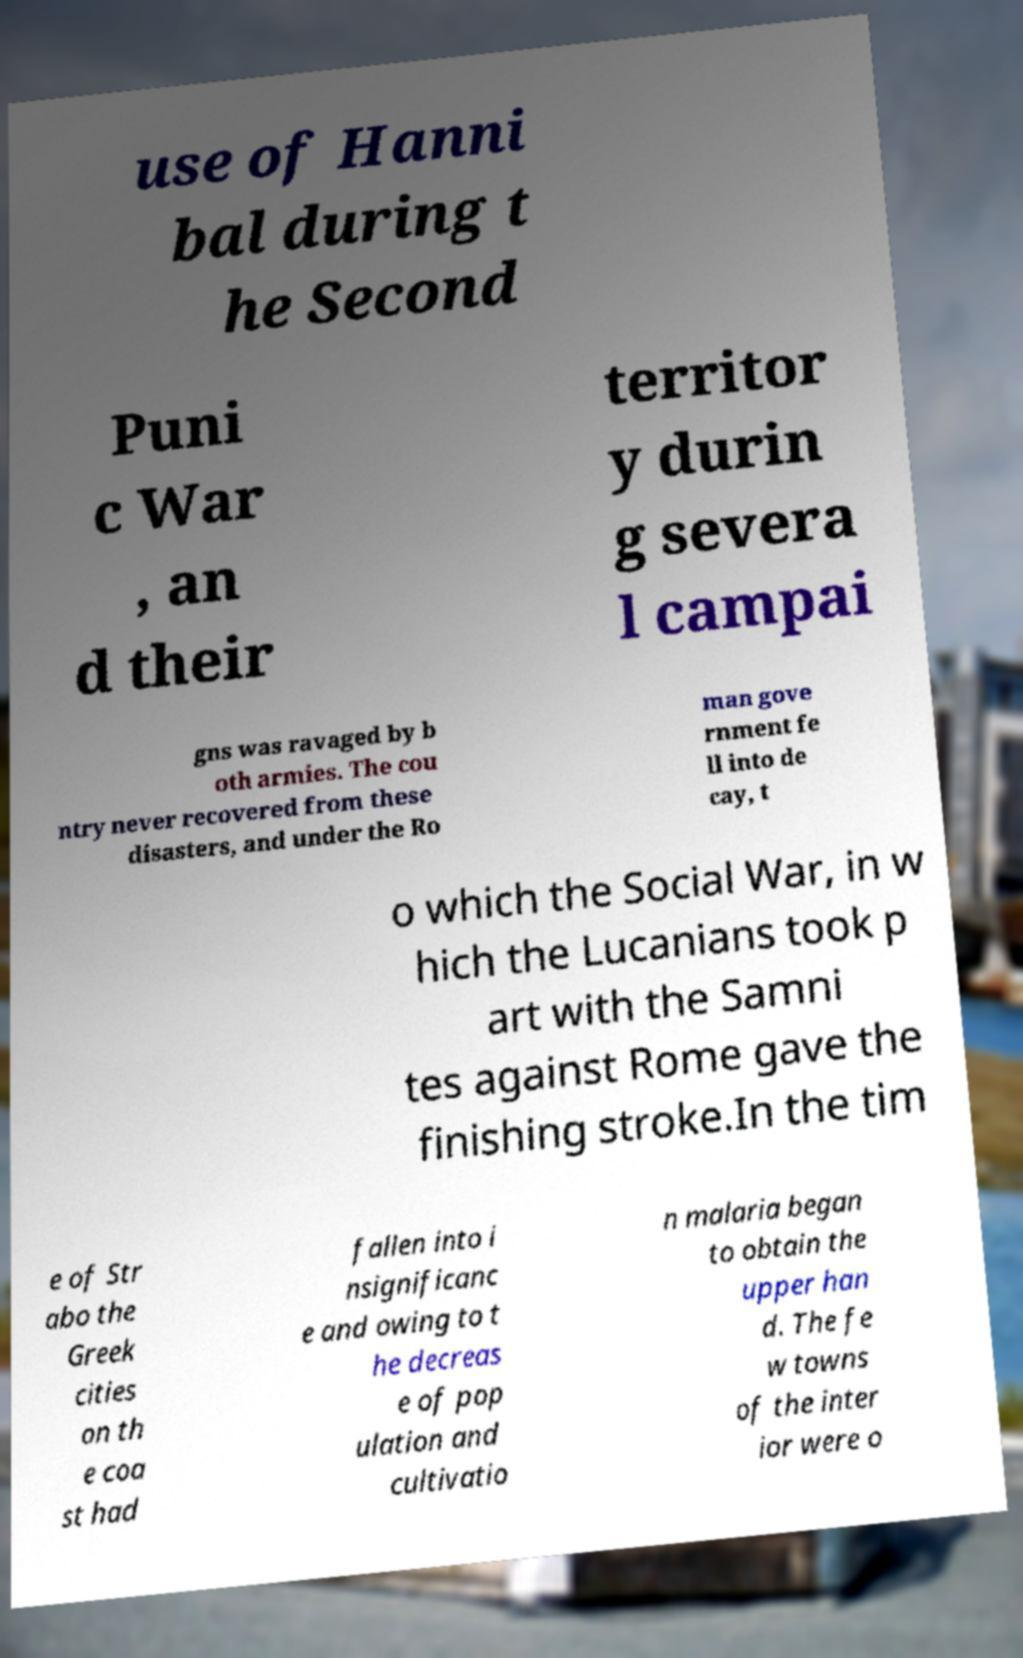Can you read and provide the text displayed in the image?This photo seems to have some interesting text. Can you extract and type it out for me? use of Hanni bal during t he Second Puni c War , an d their territor y durin g severa l campai gns was ravaged by b oth armies. The cou ntry never recovered from these disasters, and under the Ro man gove rnment fe ll into de cay, t o which the Social War, in w hich the Lucanians took p art with the Samni tes against Rome gave the finishing stroke.In the tim e of Str abo the Greek cities on th e coa st had fallen into i nsignificanc e and owing to t he decreas e of pop ulation and cultivatio n malaria began to obtain the upper han d. The fe w towns of the inter ior were o 